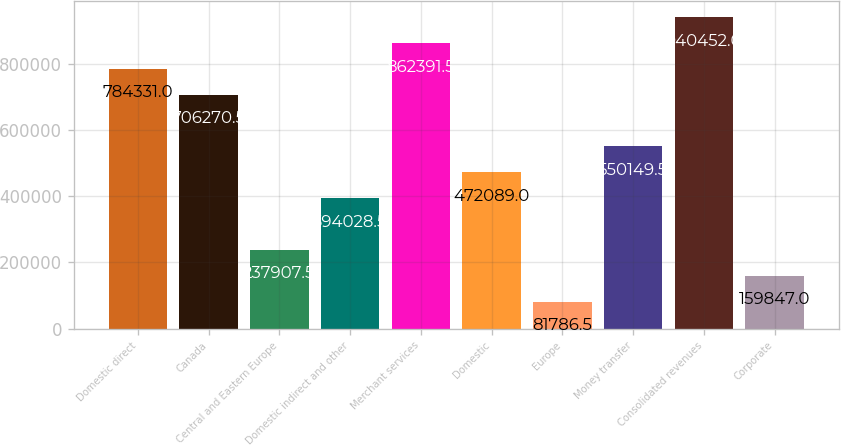Convert chart to OTSL. <chart><loc_0><loc_0><loc_500><loc_500><bar_chart><fcel>Domestic direct<fcel>Canada<fcel>Central and Eastern Europe<fcel>Domestic indirect and other<fcel>Merchant services<fcel>Domestic<fcel>Europe<fcel>Money transfer<fcel>Consolidated revenues<fcel>Corporate<nl><fcel>784331<fcel>706270<fcel>237908<fcel>394028<fcel>862392<fcel>472089<fcel>81786.5<fcel>550150<fcel>940452<fcel>159847<nl></chart> 